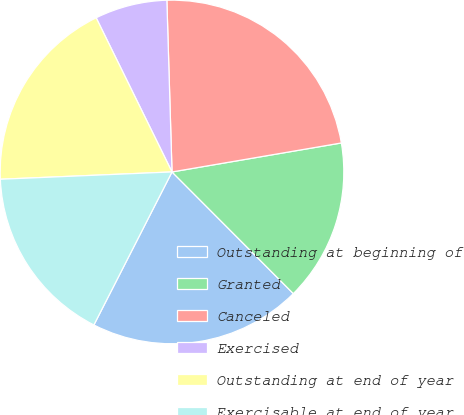Convert chart. <chart><loc_0><loc_0><loc_500><loc_500><pie_chart><fcel>Outstanding at beginning of<fcel>Granted<fcel>Canceled<fcel>Exercised<fcel>Outstanding at end of year<fcel>Exercisable at end of year<nl><fcel>19.99%<fcel>15.22%<fcel>22.78%<fcel>6.8%<fcel>18.4%<fcel>16.81%<nl></chart> 